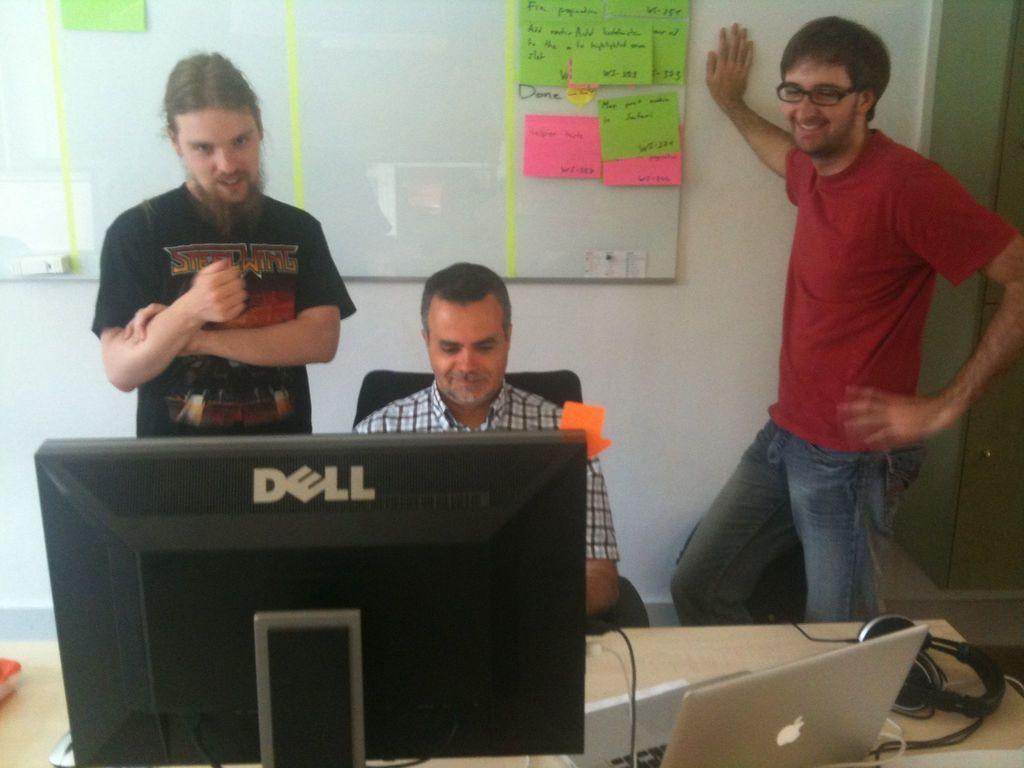Please provide a concise description of this image. In the image we can see there are two men who are standing and another man is sitting and in front of him there is a monitor, laptop and headphones on the table. 